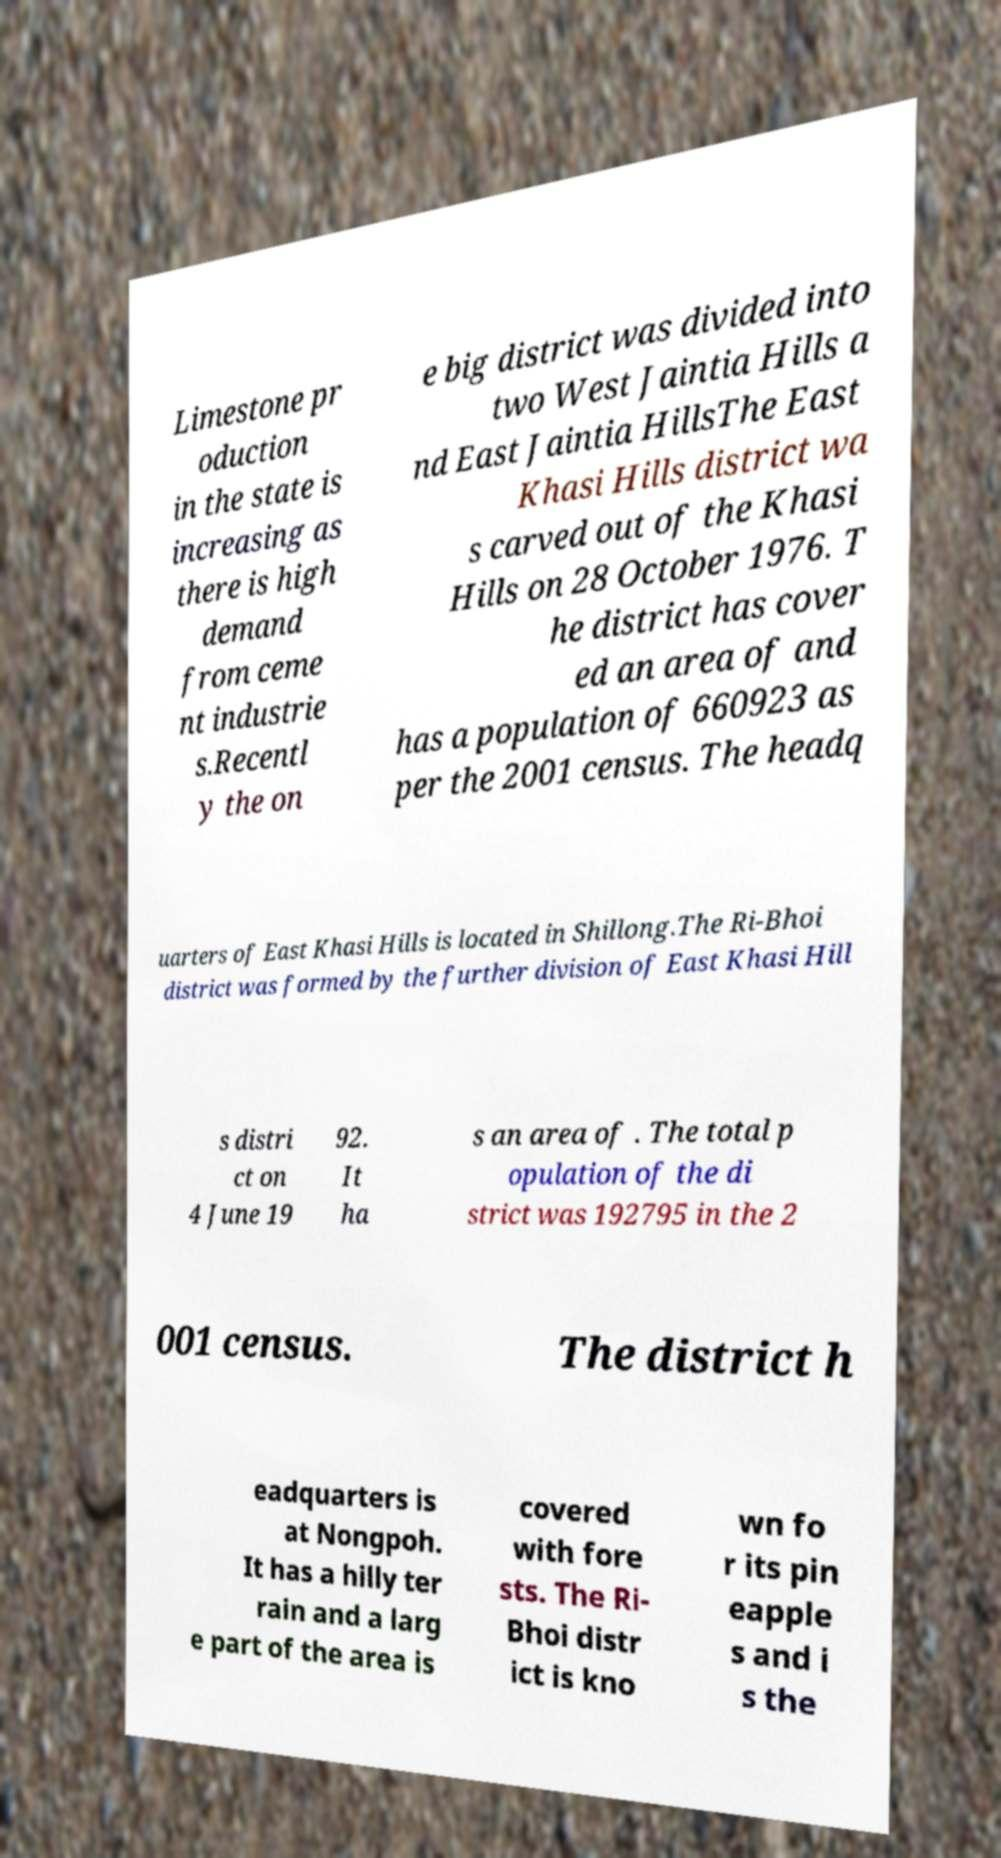Please read and relay the text visible in this image. What does it say? Limestone pr oduction in the state is increasing as there is high demand from ceme nt industrie s.Recentl y the on e big district was divided into two West Jaintia Hills a nd East Jaintia HillsThe East Khasi Hills district wa s carved out of the Khasi Hills on 28 October 1976. T he district has cover ed an area of and has a population of 660923 as per the 2001 census. The headq uarters of East Khasi Hills is located in Shillong.The Ri-Bhoi district was formed by the further division of East Khasi Hill s distri ct on 4 June 19 92. It ha s an area of . The total p opulation of the di strict was 192795 in the 2 001 census. The district h eadquarters is at Nongpoh. It has a hilly ter rain and a larg e part of the area is covered with fore sts. The Ri- Bhoi distr ict is kno wn fo r its pin eapple s and i s the 